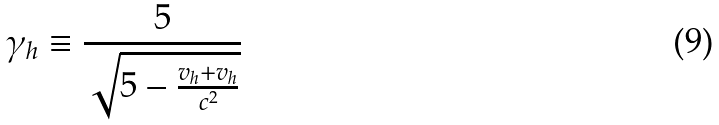Convert formula to latex. <formula><loc_0><loc_0><loc_500><loc_500>\gamma _ { h } \equiv \frac { 5 } { \sqrt { 5 - \frac { v _ { h } + v _ { h } } { c ^ { 2 } } } }</formula> 